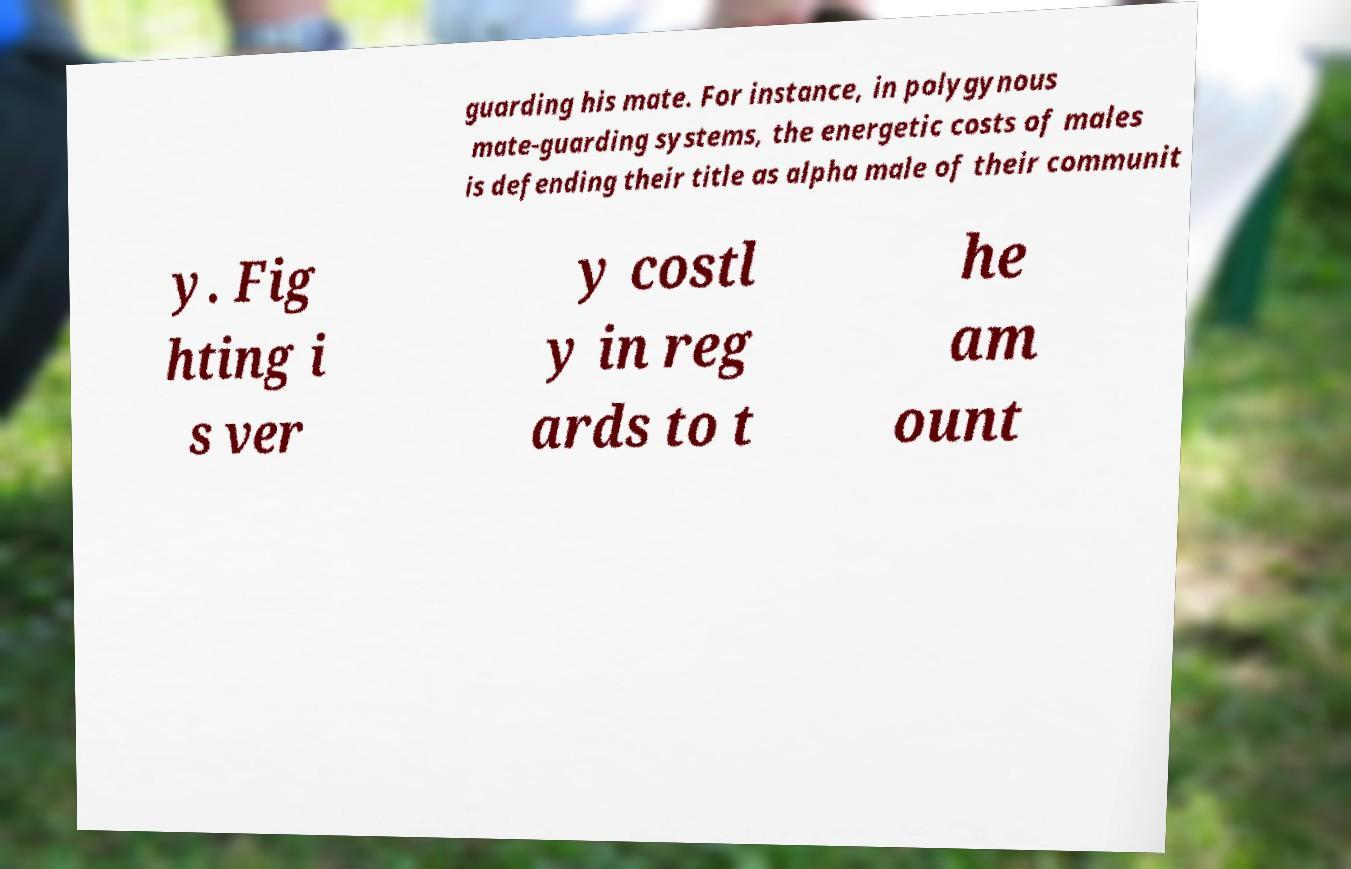There's text embedded in this image that I need extracted. Can you transcribe it verbatim? guarding his mate. For instance, in polygynous mate-guarding systems, the energetic costs of males is defending their title as alpha male of their communit y. Fig hting i s ver y costl y in reg ards to t he am ount 